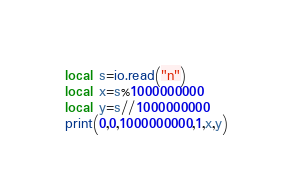Convert code to text. <code><loc_0><loc_0><loc_500><loc_500><_Lua_>local s=io.read("n")
local x=s%1000000000
local y=s//1000000000
print(0,0,1000000000,1,x,y)</code> 